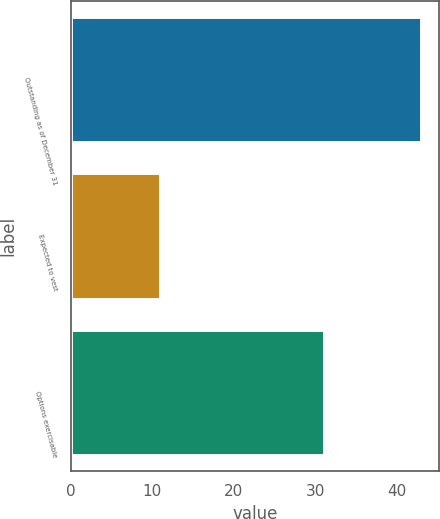Convert chart to OTSL. <chart><loc_0><loc_0><loc_500><loc_500><bar_chart><fcel>Outstanding as of December 31<fcel>Expected to vest<fcel>Options exercisable<nl><fcel>43<fcel>11<fcel>31<nl></chart> 